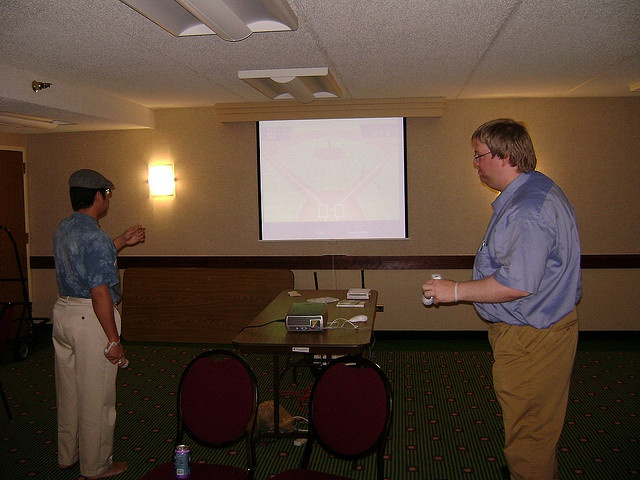Describe the objects in this image and their specific colors. I can see people in gray and maroon tones, tv in gray, lightgray, and darkgray tones, people in gray, black, and maroon tones, chair in gray, black, and maroon tones, and chair in gray, black, and maroon tones in this image. 